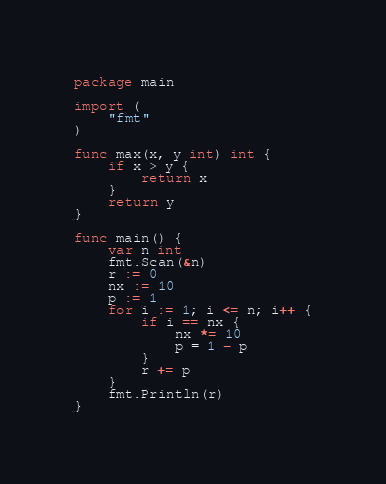<code> <loc_0><loc_0><loc_500><loc_500><_Go_>package main

import (
	"fmt"
)

func max(x, y int) int {
	if x > y {
		return x
	}
	return y
}

func main() {
	var n int
	fmt.Scan(&n)
	r := 0
	nx := 10
	p := 1
	for i := 1; i <= n; i++ {
		if i == nx {
			nx *= 10
			p = 1 - p
		}
		r += p
	}
	fmt.Println(r)
}
</code> 